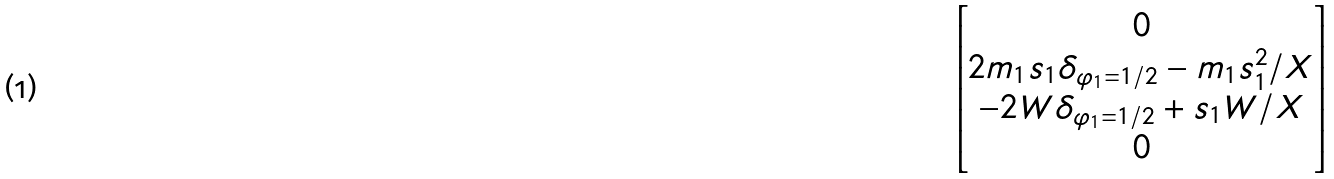<formula> <loc_0><loc_0><loc_500><loc_500>\begin{bmatrix} 0 \\ 2 m _ { 1 } s _ { 1 } \delta _ { \varphi _ { 1 } = 1 / 2 } - m _ { 1 } s _ { 1 } ^ { 2 } / X \\ - 2 W \delta _ { \varphi _ { 1 } = 1 / 2 } + s _ { 1 } W / X \\ 0 \\ \end{bmatrix}</formula> 